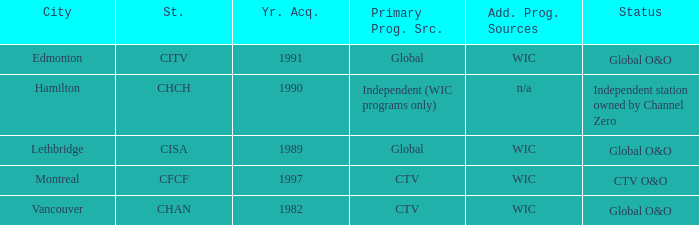How many is the minimum for citv 1991.0. 